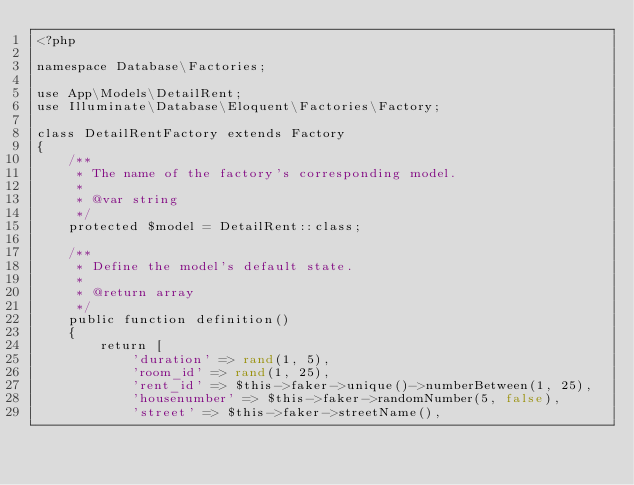Convert code to text. <code><loc_0><loc_0><loc_500><loc_500><_PHP_><?php

namespace Database\Factories;

use App\Models\DetailRent;
use Illuminate\Database\Eloquent\Factories\Factory;

class DetailRentFactory extends Factory
{
    /**
     * The name of the factory's corresponding model.
     *
     * @var string
     */
    protected $model = DetailRent::class;

    /**
     * Define the model's default state.
     *
     * @return array
     */
    public function definition()
    {
        return [
            'duration' => rand(1, 5),
            'room_id' => rand(1, 25),
            'rent_id' => $this->faker->unique()->numberBetween(1, 25),
            'housenumber' => $this->faker->randomNumber(5, false),
            'street' => $this->faker->streetName(),</code> 